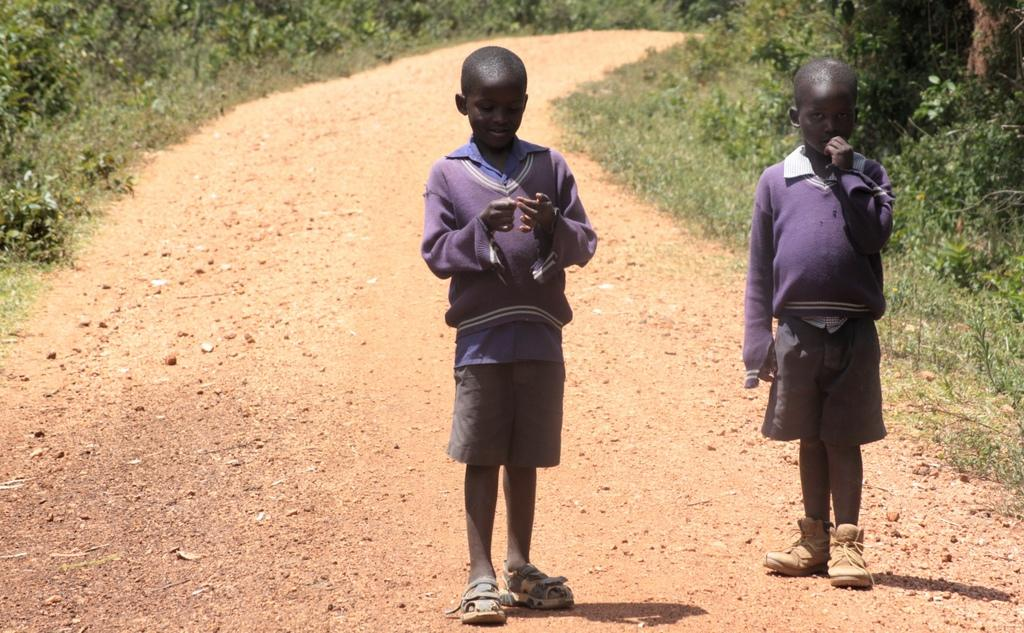Who is present in the image? There are kids in the image. What are the kids wearing? The kids are wearing clothes. What can be seen in the background of the image? There is a road and plants in the image. How many eggs are being sneezed by the plants in the image? There are no eggs or sneezing plants present in the image. 